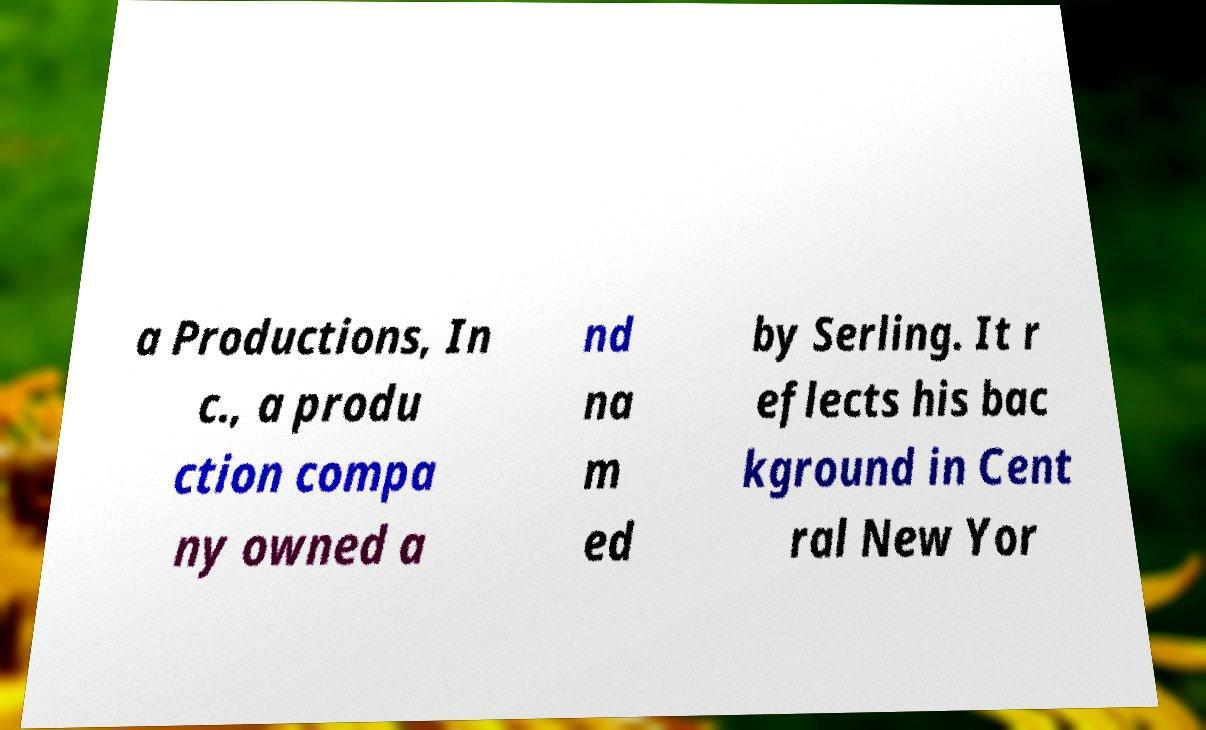Could you extract and type out the text from this image? a Productions, In c., a produ ction compa ny owned a nd na m ed by Serling. It r eflects his bac kground in Cent ral New Yor 